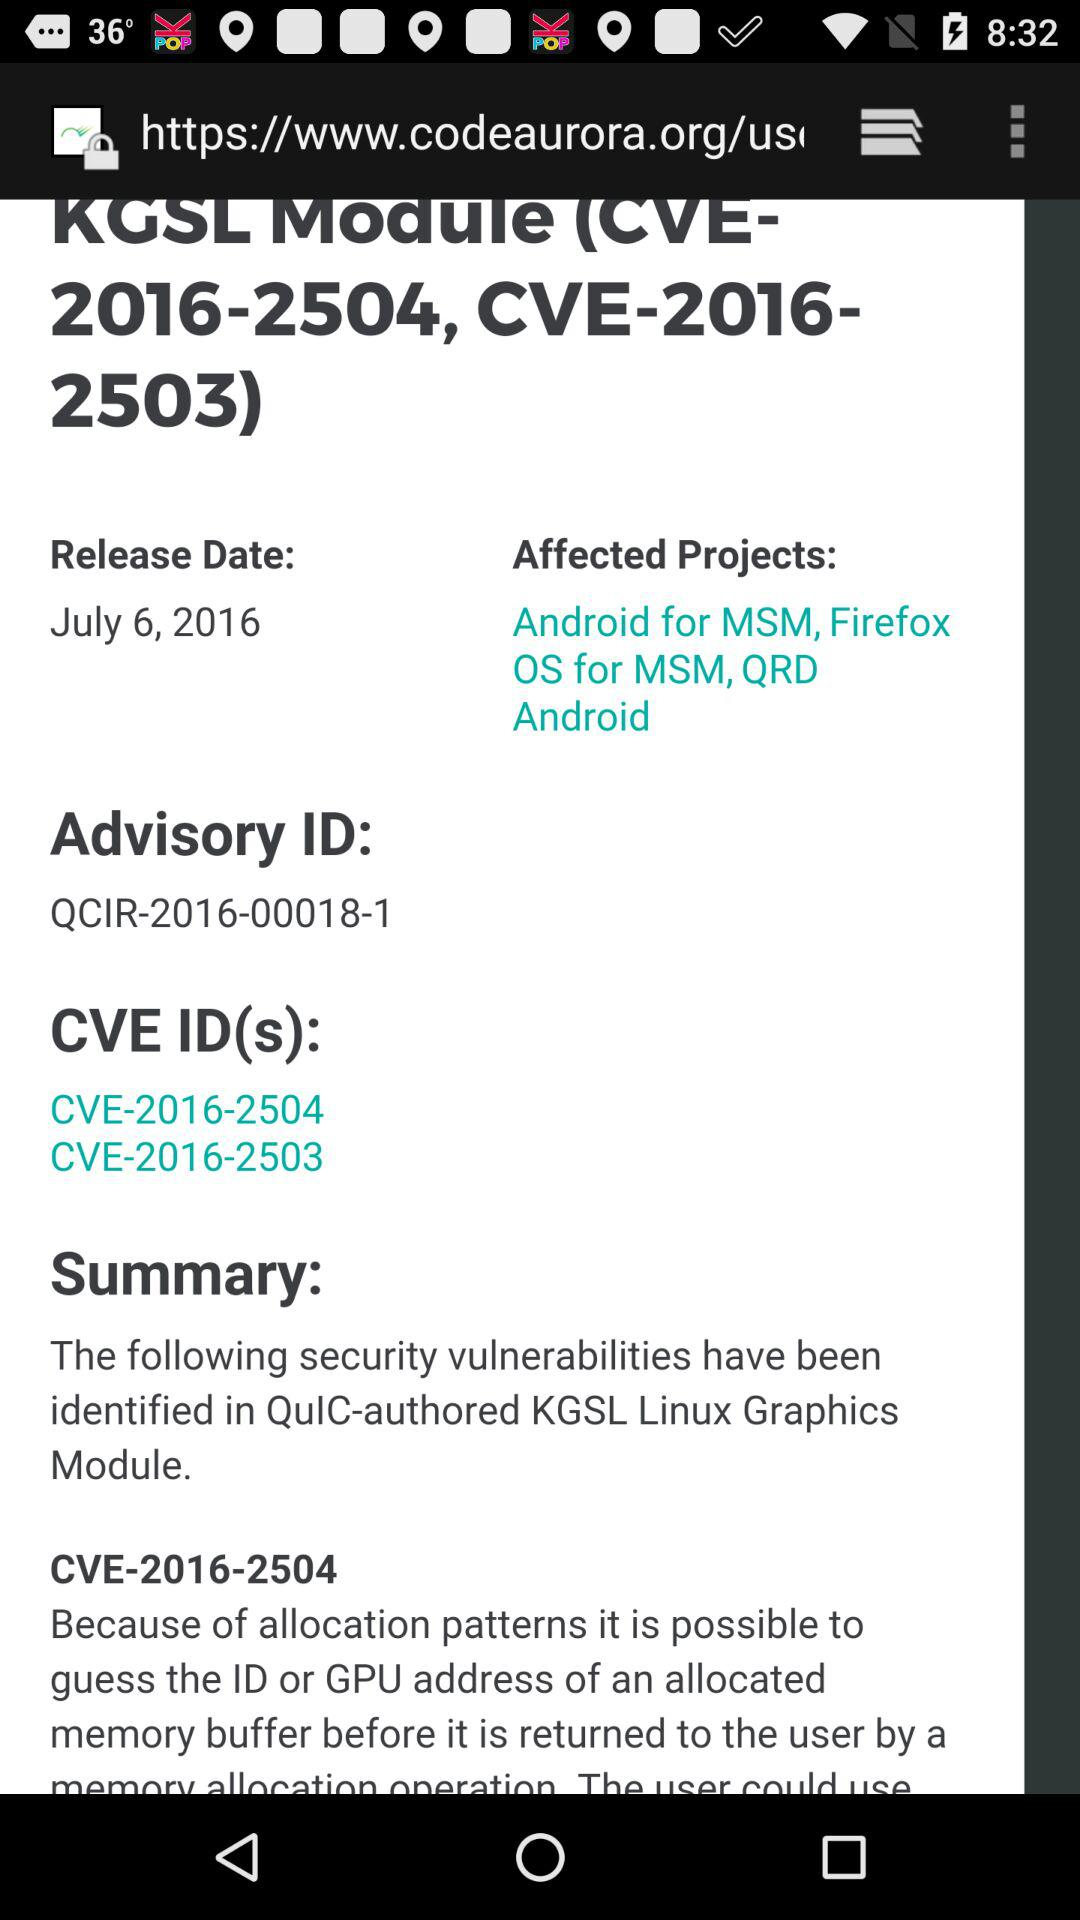What is the topic of the article? The topic of the article is "KGSL Module (CVE- 2016-2504, CVE-2016- 2503)". 